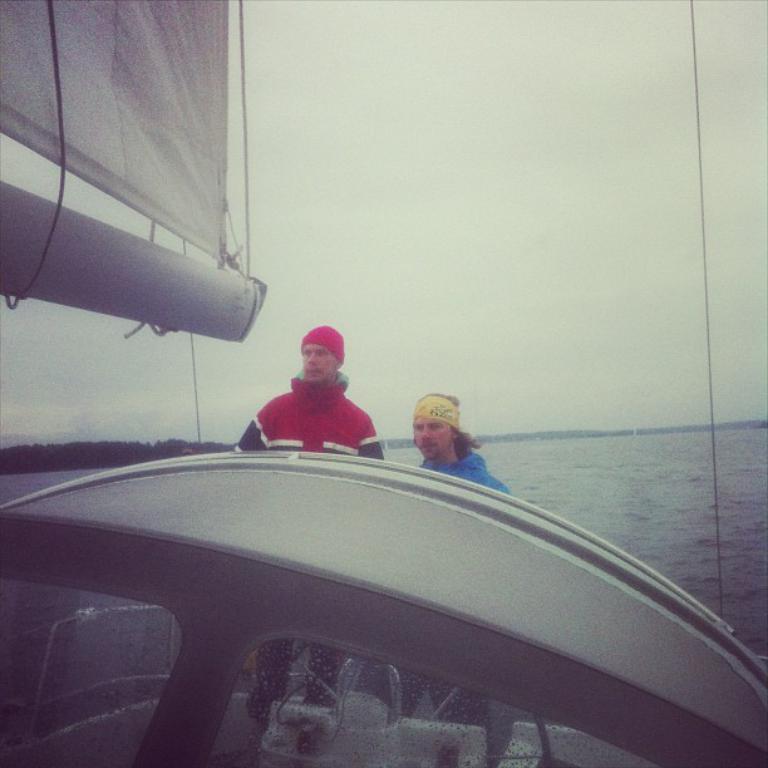Please provide a concise description of this image. In this image there is an object. On that object there are two persons standing and at the top there is a cloth tie to the object. In the background there is a water, Trees and a sky. 